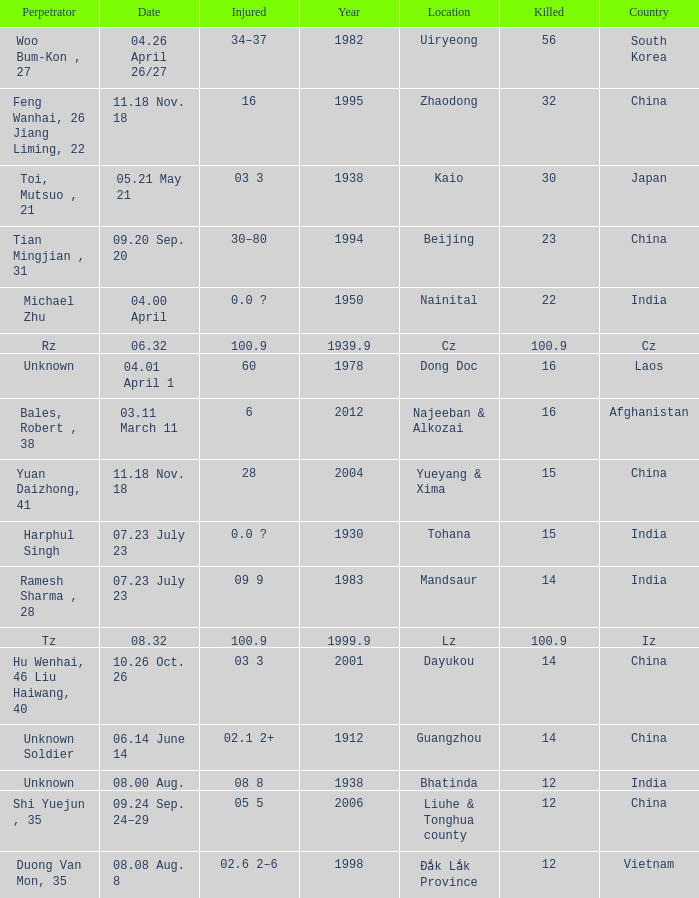What is Injured, when Country is "Afghanistan"? 6.0. Help me parse the entirety of this table. {'header': ['Perpetrator', 'Date', 'Injured', 'Year', 'Location', 'Killed', 'Country'], 'rows': [['Woo Bum-Kon , 27', '04.26 April 26/27', '34–37', '1982', 'Uiryeong', '56', 'South Korea'], ['Feng Wanhai, 26 Jiang Liming, 22', '11.18 Nov. 18', '16', '1995', 'Zhaodong', '32', 'China'], ['Toi, Mutsuo , 21', '05.21 May 21', '03 3', '1938', 'Kaio', '30', 'Japan'], ['Tian Mingjian , 31', '09.20 Sep. 20', '30–80', '1994', 'Beijing', '23', 'China'], ['Michael Zhu', '04.00 April', '0.0 ?', '1950', 'Nainital', '22', 'India'], ['Rz', '06.32', '100.9', '1939.9', 'Cz', '100.9', 'Cz'], ['Unknown', '04.01 April 1', '60', '1978', 'Dong Doc', '16', 'Laos'], ['Bales, Robert , 38', '03.11 March 11', '6', '2012', 'Najeeban & Alkozai', '16', 'Afghanistan'], ['Yuan Daizhong, 41', '11.18 Nov. 18', '28', '2004', 'Yueyang & Xima', '15', 'China'], ['Harphul Singh', '07.23 July 23', '0.0 ?', '1930', 'Tohana', '15', 'India'], ['Ramesh Sharma , 28', '07.23 July 23', '09 9', '1983', 'Mandsaur', '14', 'India'], ['Tz', '08.32', '100.9', '1999.9', 'Lz', '100.9', 'Iz'], ['Hu Wenhai, 46 Liu Haiwang, 40', '10.26 Oct. 26', '03 3', '2001', 'Dayukou', '14', 'China'], ['Unknown Soldier', '06.14 June 14', '02.1 2+', '1912', 'Guangzhou', '14', 'China'], ['Unknown', '08.00 Aug.', '08 8', '1938', 'Bhatinda', '12', 'India'], ['Shi Yuejun , 35', '09.24 Sep. 24–29', '05 5', '2006', 'Liuhe & Tonghua county', '12', 'China'], ['Duong Van Mon, 35', '08.08 Aug. 8', '02.6 2–6', '1998', 'Đắk Lắk Province', '12', 'Vietnam']]} 